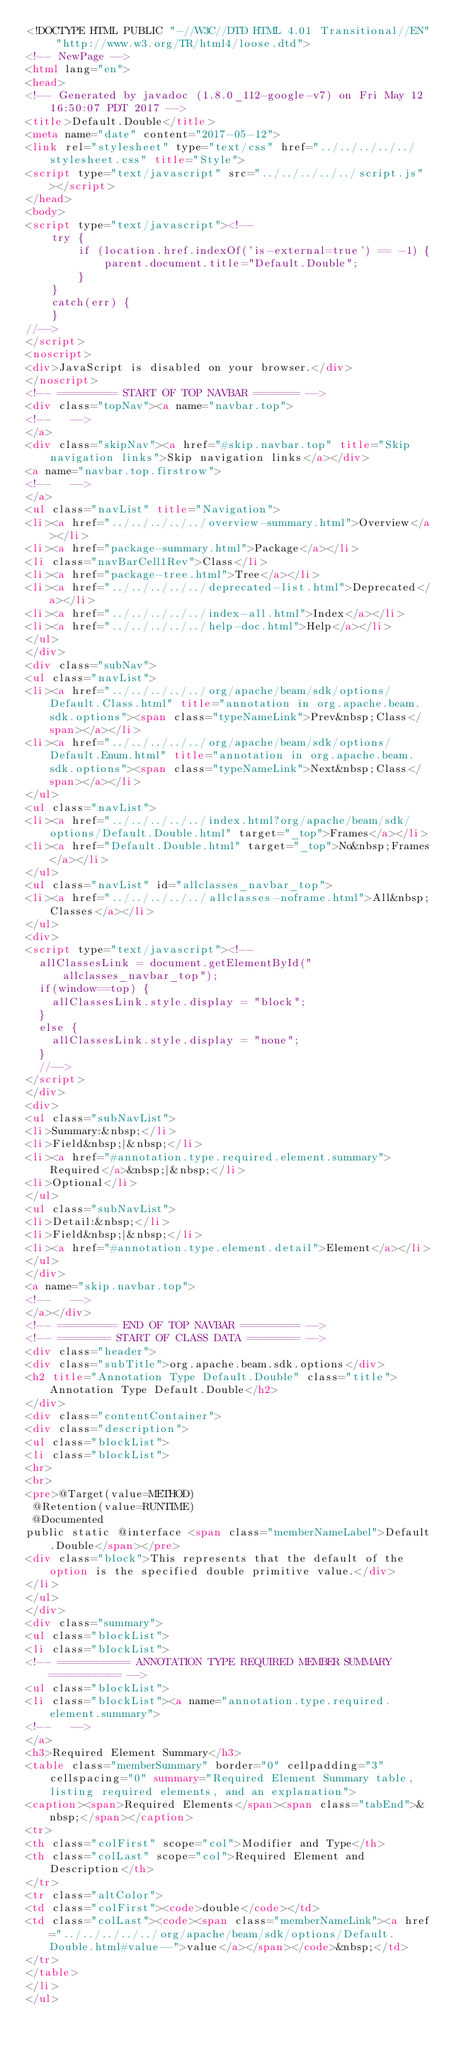Convert code to text. <code><loc_0><loc_0><loc_500><loc_500><_HTML_><!DOCTYPE HTML PUBLIC "-//W3C//DTD HTML 4.01 Transitional//EN" "http://www.w3.org/TR/html4/loose.dtd">
<!-- NewPage -->
<html lang="en">
<head>
<!-- Generated by javadoc (1.8.0_112-google-v7) on Fri May 12 16:50:07 PDT 2017 -->
<title>Default.Double</title>
<meta name="date" content="2017-05-12">
<link rel="stylesheet" type="text/css" href="../../../../../stylesheet.css" title="Style">
<script type="text/javascript" src="../../../../../script.js"></script>
</head>
<body>
<script type="text/javascript"><!--
    try {
        if (location.href.indexOf('is-external=true') == -1) {
            parent.document.title="Default.Double";
        }
    }
    catch(err) {
    }
//-->
</script>
<noscript>
<div>JavaScript is disabled on your browser.</div>
</noscript>
<!-- ========= START OF TOP NAVBAR ======= -->
<div class="topNav"><a name="navbar.top">
<!--   -->
</a>
<div class="skipNav"><a href="#skip.navbar.top" title="Skip navigation links">Skip navigation links</a></div>
<a name="navbar.top.firstrow">
<!--   -->
</a>
<ul class="navList" title="Navigation">
<li><a href="../../../../../overview-summary.html">Overview</a></li>
<li><a href="package-summary.html">Package</a></li>
<li class="navBarCell1Rev">Class</li>
<li><a href="package-tree.html">Tree</a></li>
<li><a href="../../../../../deprecated-list.html">Deprecated</a></li>
<li><a href="../../../../../index-all.html">Index</a></li>
<li><a href="../../../../../help-doc.html">Help</a></li>
</ul>
</div>
<div class="subNav">
<ul class="navList">
<li><a href="../../../../../org/apache/beam/sdk/options/Default.Class.html" title="annotation in org.apache.beam.sdk.options"><span class="typeNameLink">Prev&nbsp;Class</span></a></li>
<li><a href="../../../../../org/apache/beam/sdk/options/Default.Enum.html" title="annotation in org.apache.beam.sdk.options"><span class="typeNameLink">Next&nbsp;Class</span></a></li>
</ul>
<ul class="navList">
<li><a href="../../../../../index.html?org/apache/beam/sdk/options/Default.Double.html" target="_top">Frames</a></li>
<li><a href="Default.Double.html" target="_top">No&nbsp;Frames</a></li>
</ul>
<ul class="navList" id="allclasses_navbar_top">
<li><a href="../../../../../allclasses-noframe.html">All&nbsp;Classes</a></li>
</ul>
<div>
<script type="text/javascript"><!--
  allClassesLink = document.getElementById("allclasses_navbar_top");
  if(window==top) {
    allClassesLink.style.display = "block";
  }
  else {
    allClassesLink.style.display = "none";
  }
  //-->
</script>
</div>
<div>
<ul class="subNavList">
<li>Summary:&nbsp;</li>
<li>Field&nbsp;|&nbsp;</li>
<li><a href="#annotation.type.required.element.summary">Required</a>&nbsp;|&nbsp;</li>
<li>Optional</li>
</ul>
<ul class="subNavList">
<li>Detail:&nbsp;</li>
<li>Field&nbsp;|&nbsp;</li>
<li><a href="#annotation.type.element.detail">Element</a></li>
</ul>
</div>
<a name="skip.navbar.top">
<!--   -->
</a></div>
<!-- ========= END OF TOP NAVBAR ========= -->
<!-- ======== START OF CLASS DATA ======== -->
<div class="header">
<div class="subTitle">org.apache.beam.sdk.options</div>
<h2 title="Annotation Type Default.Double" class="title">Annotation Type Default.Double</h2>
</div>
<div class="contentContainer">
<div class="description">
<ul class="blockList">
<li class="blockList">
<hr>
<br>
<pre>@Target(value=METHOD)
 @Retention(value=RUNTIME)
 @Documented
public static @interface <span class="memberNameLabel">Default.Double</span></pre>
<div class="block">This represents that the default of the option is the specified double primitive value.</div>
</li>
</ul>
</div>
<div class="summary">
<ul class="blockList">
<li class="blockList">
<!-- =========== ANNOTATION TYPE REQUIRED MEMBER SUMMARY =========== -->
<ul class="blockList">
<li class="blockList"><a name="annotation.type.required.element.summary">
<!--   -->
</a>
<h3>Required Element Summary</h3>
<table class="memberSummary" border="0" cellpadding="3" cellspacing="0" summary="Required Element Summary table, listing required elements, and an explanation">
<caption><span>Required Elements</span><span class="tabEnd">&nbsp;</span></caption>
<tr>
<th class="colFirst" scope="col">Modifier and Type</th>
<th class="colLast" scope="col">Required Element and Description</th>
</tr>
<tr class="altColor">
<td class="colFirst"><code>double</code></td>
<td class="colLast"><code><span class="memberNameLink"><a href="../../../../../org/apache/beam/sdk/options/Default.Double.html#value--">value</a></span></code>&nbsp;</td>
</tr>
</table>
</li>
</ul></code> 